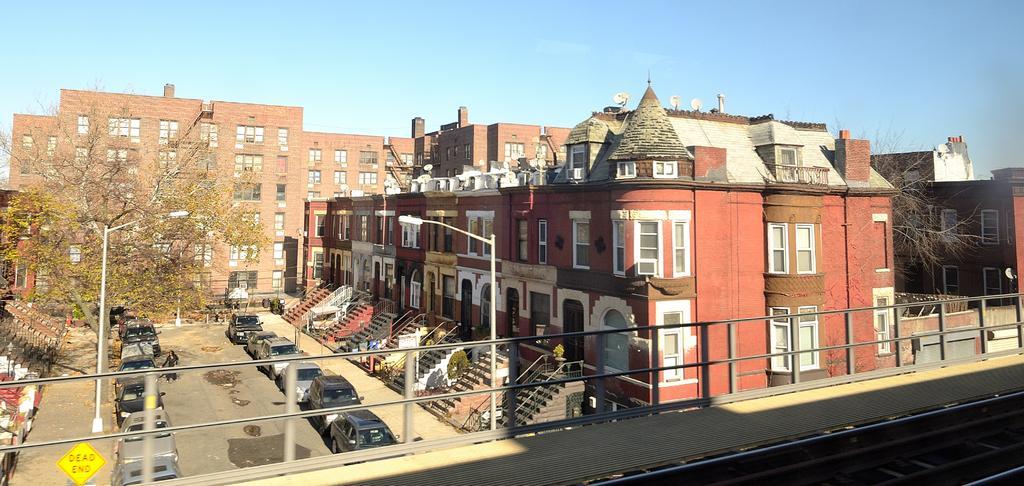In one or two sentences, can you explain what this image depicts? In this image I can see buildings , in front of the buildings i can see staircase and vehicles parking on the road an d I can see trees and poles on the left side at the top I can see sky and at the bottom I can see bridge 